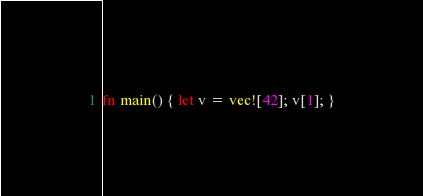<code> <loc_0><loc_0><loc_500><loc_500><_Rust_>fn main() { let v = vec![42]; v[1]; }
</code> 